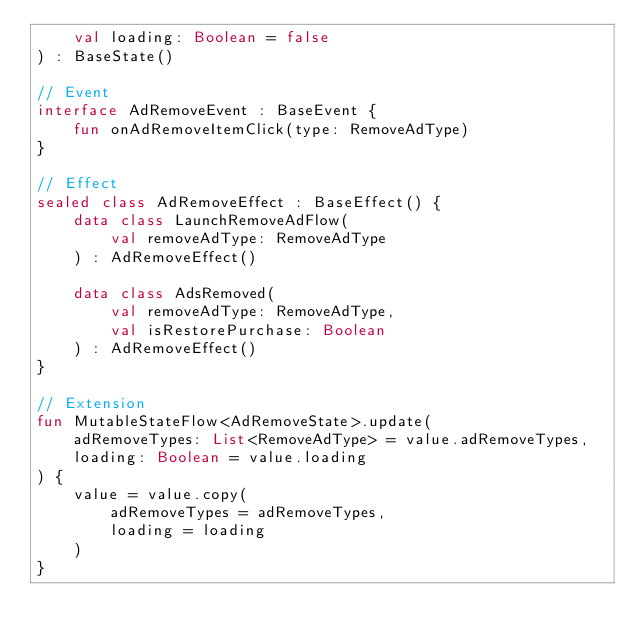Convert code to text. <code><loc_0><loc_0><loc_500><loc_500><_Kotlin_>    val loading: Boolean = false
) : BaseState()

// Event
interface AdRemoveEvent : BaseEvent {
    fun onAdRemoveItemClick(type: RemoveAdType)
}

// Effect
sealed class AdRemoveEffect : BaseEffect() {
    data class LaunchRemoveAdFlow(
        val removeAdType: RemoveAdType
    ) : AdRemoveEffect()

    data class AdsRemoved(
        val removeAdType: RemoveAdType,
        val isRestorePurchase: Boolean
    ) : AdRemoveEffect()
}

// Extension
fun MutableStateFlow<AdRemoveState>.update(
    adRemoveTypes: List<RemoveAdType> = value.adRemoveTypes,
    loading: Boolean = value.loading
) {
    value = value.copy(
        adRemoveTypes = adRemoveTypes,
        loading = loading
    )
}
</code> 